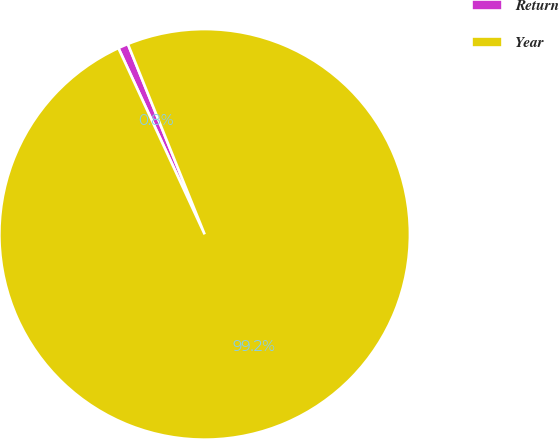<chart> <loc_0><loc_0><loc_500><loc_500><pie_chart><fcel>Return<fcel>Year<nl><fcel>0.8%<fcel>99.2%<nl></chart> 